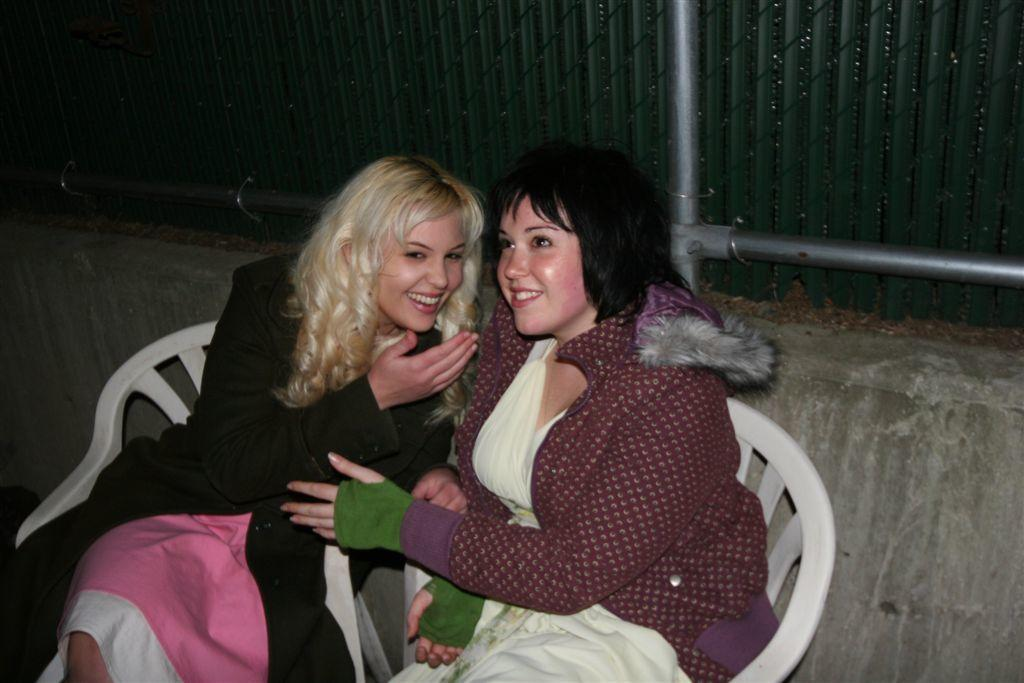How many people are in the image? There are two people in the image. What are the people doing in the image? The people are sitting on chairs. What are the people wearing in the image? The people are wearing jackets. What expression do the people have in the image? The people are smiling. What can be seen in the background of the image? There are pipes, a wall, and fencing in the background of the image. What type of beds can be seen in the image? There are no beds present in the image. What drink is the person holding in the image? There is no drink visible in the image. 